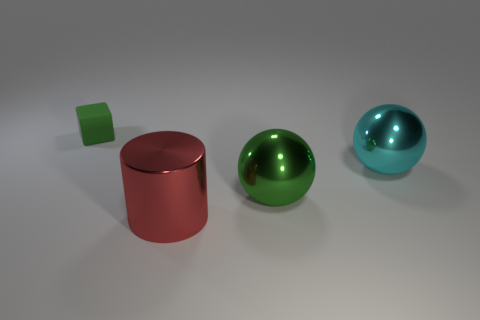Add 1 green cubes. How many objects exist? 5 Subtract all cylinders. How many objects are left? 3 Add 3 cylinders. How many cylinders are left? 4 Add 4 large cylinders. How many large cylinders exist? 5 Subtract 0 yellow cubes. How many objects are left? 4 Subtract 1 blocks. How many blocks are left? 0 Subtract all green spheres. Subtract all red cubes. How many spheres are left? 1 Subtract all brown cylinders. How many yellow balls are left? 0 Subtract all cylinders. Subtract all big yellow matte balls. How many objects are left? 3 